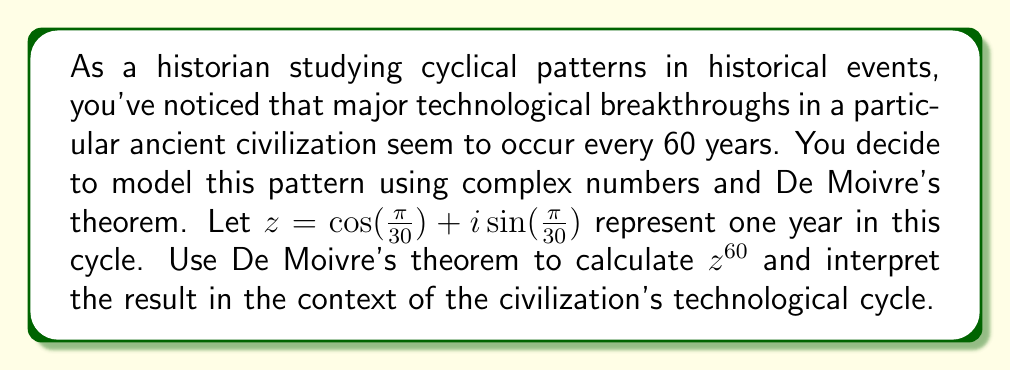Can you answer this question? To solve this problem, we'll use De Moivre's theorem and interpret the result:

1) De Moivre's theorem states that for any real number $x$ and integer $n$:

   $(\cos x + i \sin x)^n = \cos(nx) + i \sin(nx)$

2) In our case, $x = \frac{\pi}{30}$ and $n = 60$. Let's substitute these values:

   $z^{60} = (\cos(\frac{\pi}{30}) + i\sin(\frac{\pi}{30}))^{60} = \cos(60 \cdot \frac{\pi}{30}) + i \sin(60 \cdot \frac{\pi}{30})$

3) Simplify the argument:

   $60 \cdot \frac{\pi}{30} = 2\pi$

4) Therefore:

   $z^{60} = \cos(2\pi) + i \sin(2\pi)$

5) Recall that $\cos(2\pi) = 1$ and $\sin(2\pi) = 0$. So:

   $z^{60} = 1 + 0i = 1$

6) Interpretation: The result $z^{60} = 1$ means that after 60 years, we've completed a full cycle and returned to our starting point. This aligns with the observation that major technological breakthroughs occur every 60 years in this civilization.

This mathematical model using complex numbers and De Moivre's theorem elegantly captures the cyclical nature of these historical events, providing a quantitative framework for analyzing periodic patterns in history.
Answer: $z^{60} = 1$, indicating a complete cycle every 60 years, which aligns with the observed pattern of technological breakthroughs in the ancient civilization. 